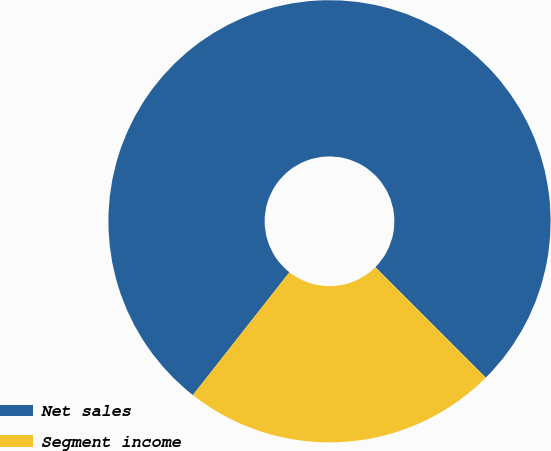Convert chart. <chart><loc_0><loc_0><loc_500><loc_500><pie_chart><fcel>Net sales<fcel>Segment income<nl><fcel>76.9%<fcel>23.1%<nl></chart> 